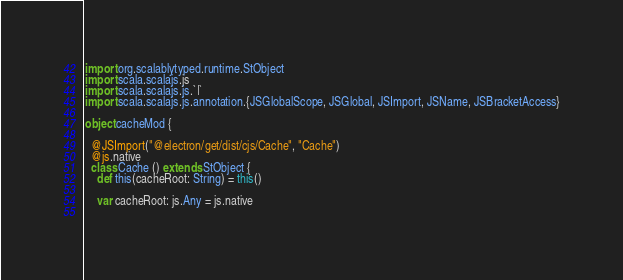Convert code to text. <code><loc_0><loc_0><loc_500><loc_500><_Scala_>
import org.scalablytyped.runtime.StObject
import scala.scalajs.js
import scala.scalajs.js.`|`
import scala.scalajs.js.annotation.{JSGlobalScope, JSGlobal, JSImport, JSName, JSBracketAccess}

object cacheMod {
  
  @JSImport("@electron/get/dist/cjs/Cache", "Cache")
  @js.native
  class Cache () extends StObject {
    def this(cacheRoot: String) = this()
    
    var cacheRoot: js.Any = js.native
    </code> 